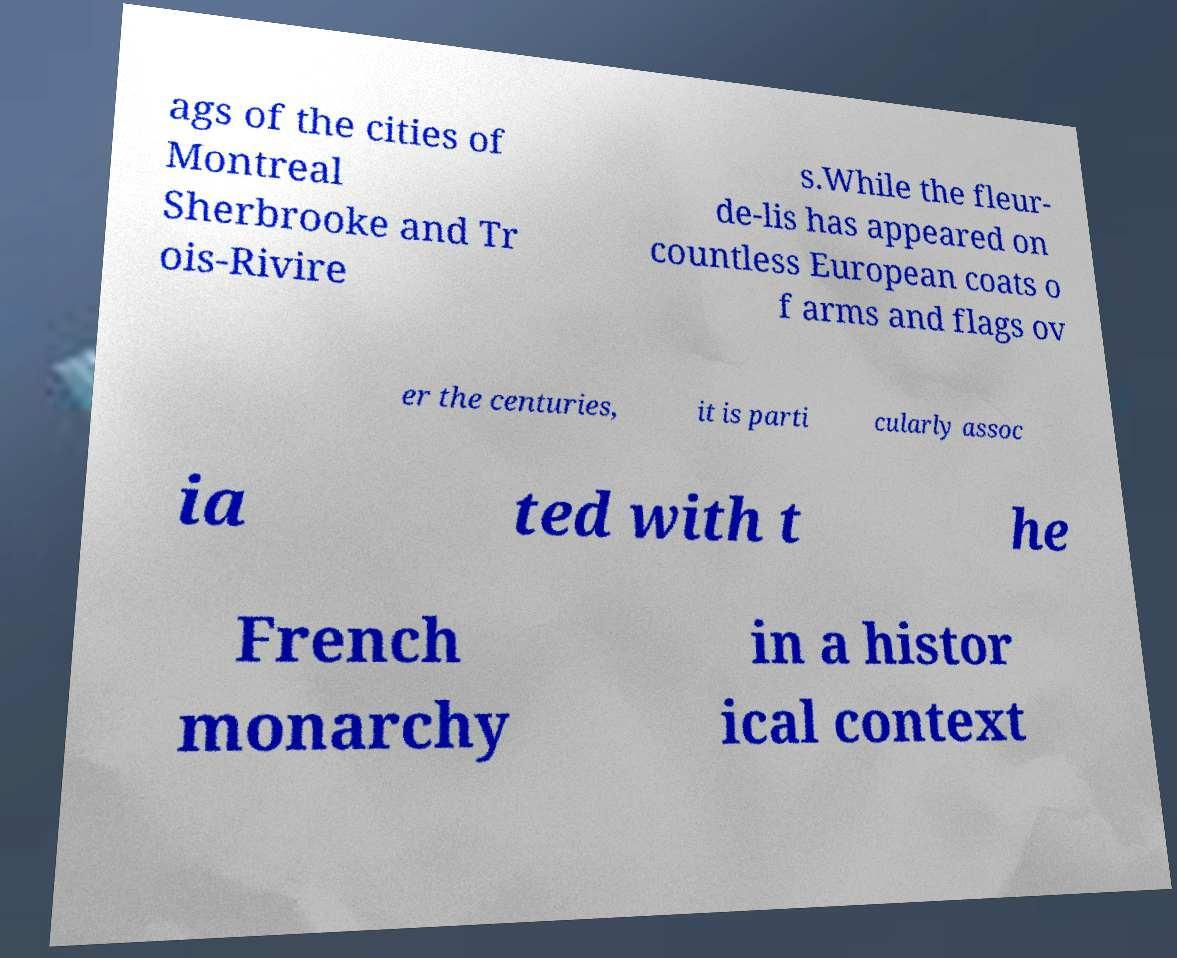Could you assist in decoding the text presented in this image and type it out clearly? ags of the cities of Montreal Sherbrooke and Tr ois-Rivire s.While the fleur- de-lis has appeared on countless European coats o f arms and flags ov er the centuries, it is parti cularly assoc ia ted with t he French monarchy in a histor ical context 